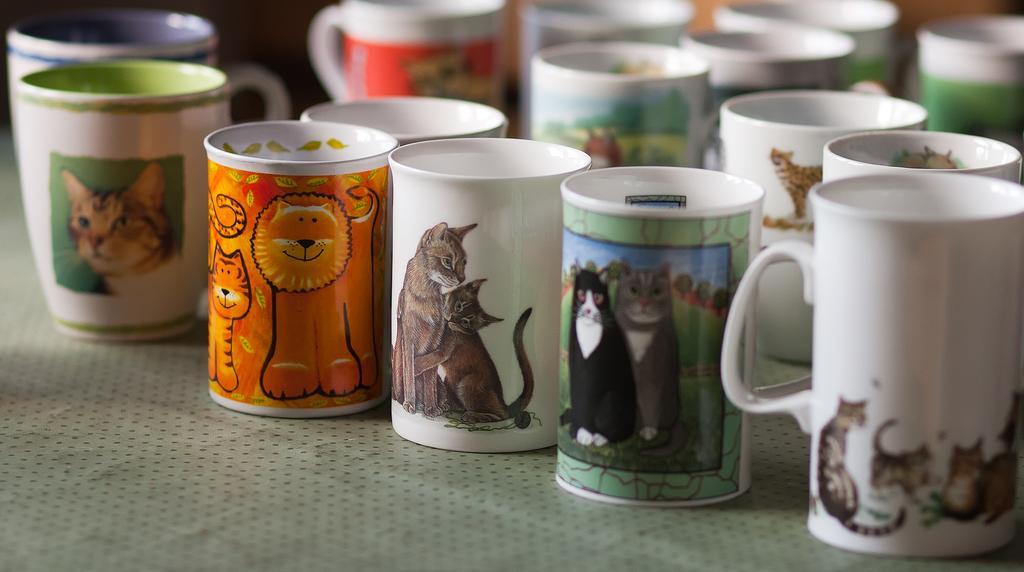Please provide a concise description of this image. In this image there are a group of cups and on the cups there is some art, and at the bottom of the image it looks like a table. 